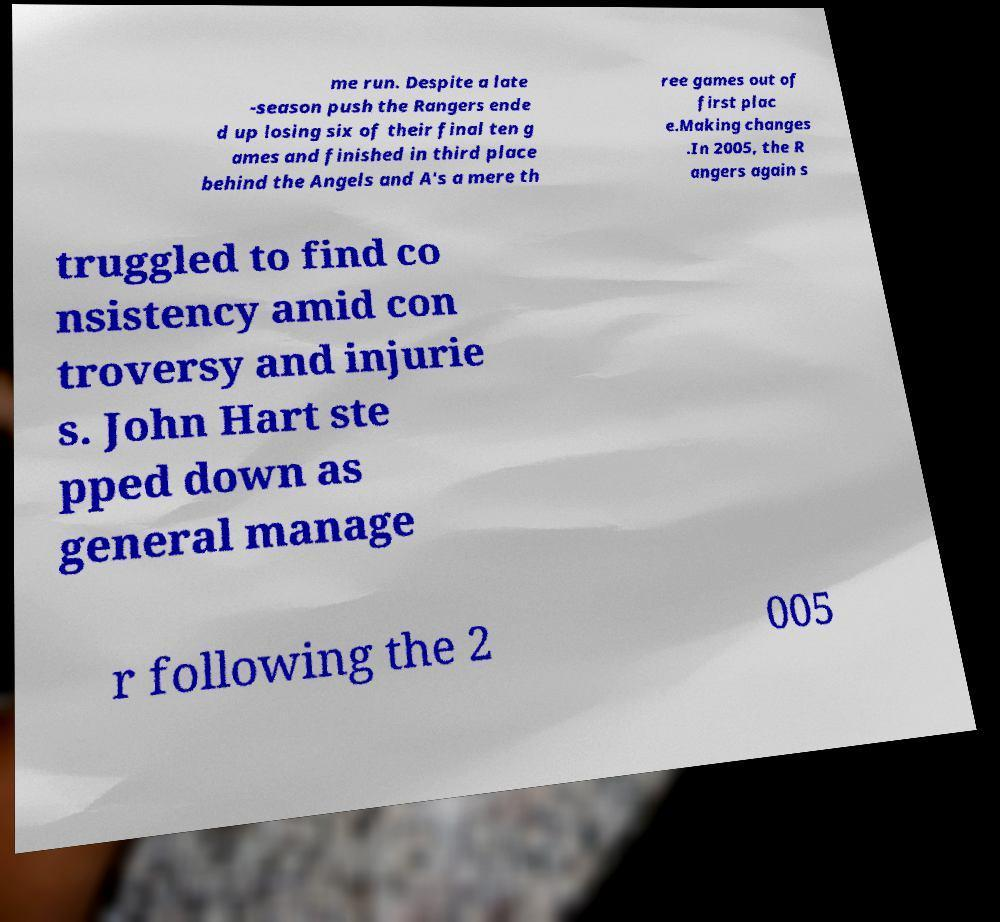There's text embedded in this image that I need extracted. Can you transcribe it verbatim? me run. Despite a late -season push the Rangers ende d up losing six of their final ten g ames and finished in third place behind the Angels and A's a mere th ree games out of first plac e.Making changes .In 2005, the R angers again s truggled to find co nsistency amid con troversy and injurie s. John Hart ste pped down as general manage r following the 2 005 